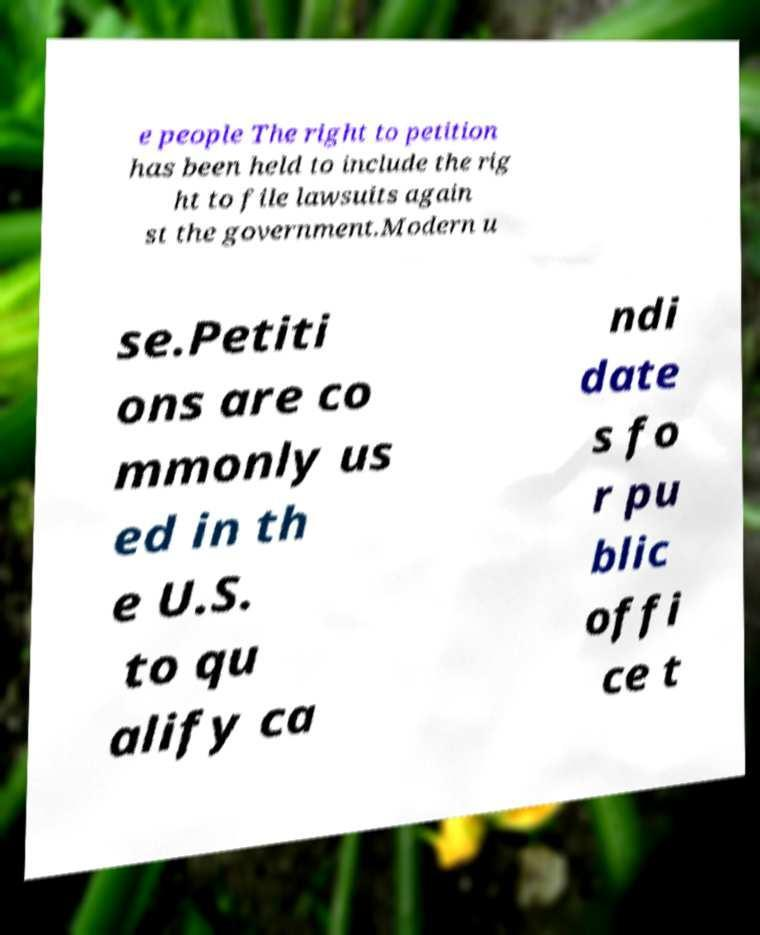Could you extract and type out the text from this image? e people The right to petition has been held to include the rig ht to file lawsuits again st the government.Modern u se.Petiti ons are co mmonly us ed in th e U.S. to qu alify ca ndi date s fo r pu blic offi ce t 